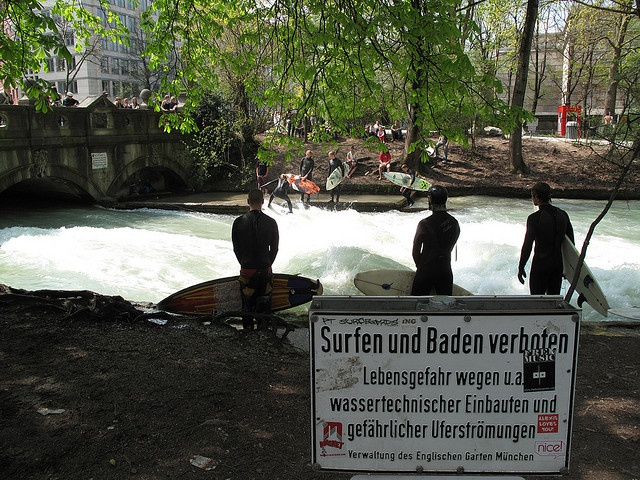Describe the objects in this image and their specific colors. I can see people in gray, black, and white tones, people in gray, black, white, and darkgray tones, surfboard in gray, black, and darkgreen tones, people in gray, black, ivory, and darkgray tones, and surfboard in gray, darkgreen, and black tones in this image. 